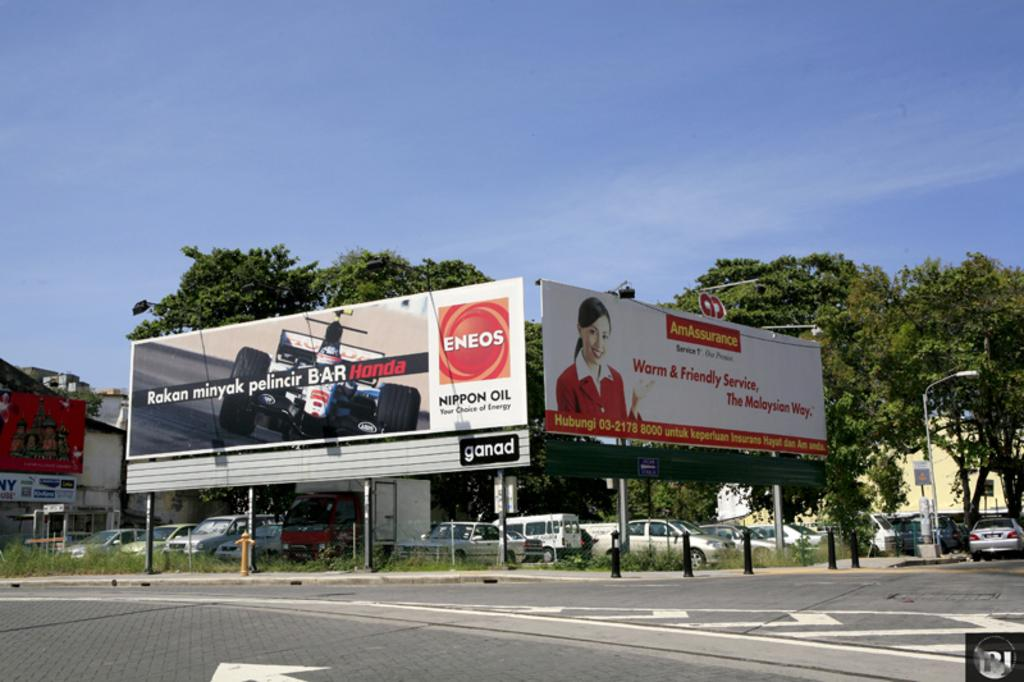Provide a one-sentence caption for the provided image. A billboard for Eneos Nippon Oil sits on a corner of a street. 